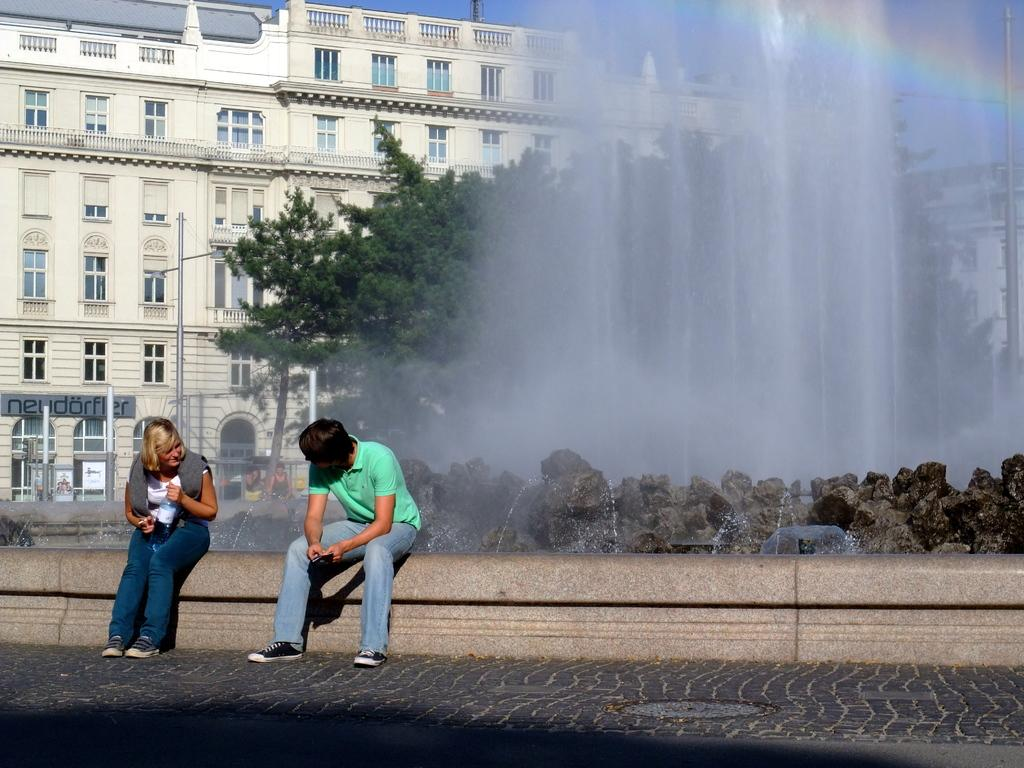What type of surface can be seen in the image? There is ground visible in the image. What are the two people in the image doing? They are sitting on a wall in the image. What can be seen in the distance behind the wall? There are buildings, trees, people, water, poles, stones, and the sky visible in the background of the image. What crime is being committed by the two people sitting on the wall in the image? There is no indication of any crime being committed in the image; the two people are simply sitting on a wall. Who is the partner of the person sitting on the wall in the image? There is no information about any partners or relationships in the image. 